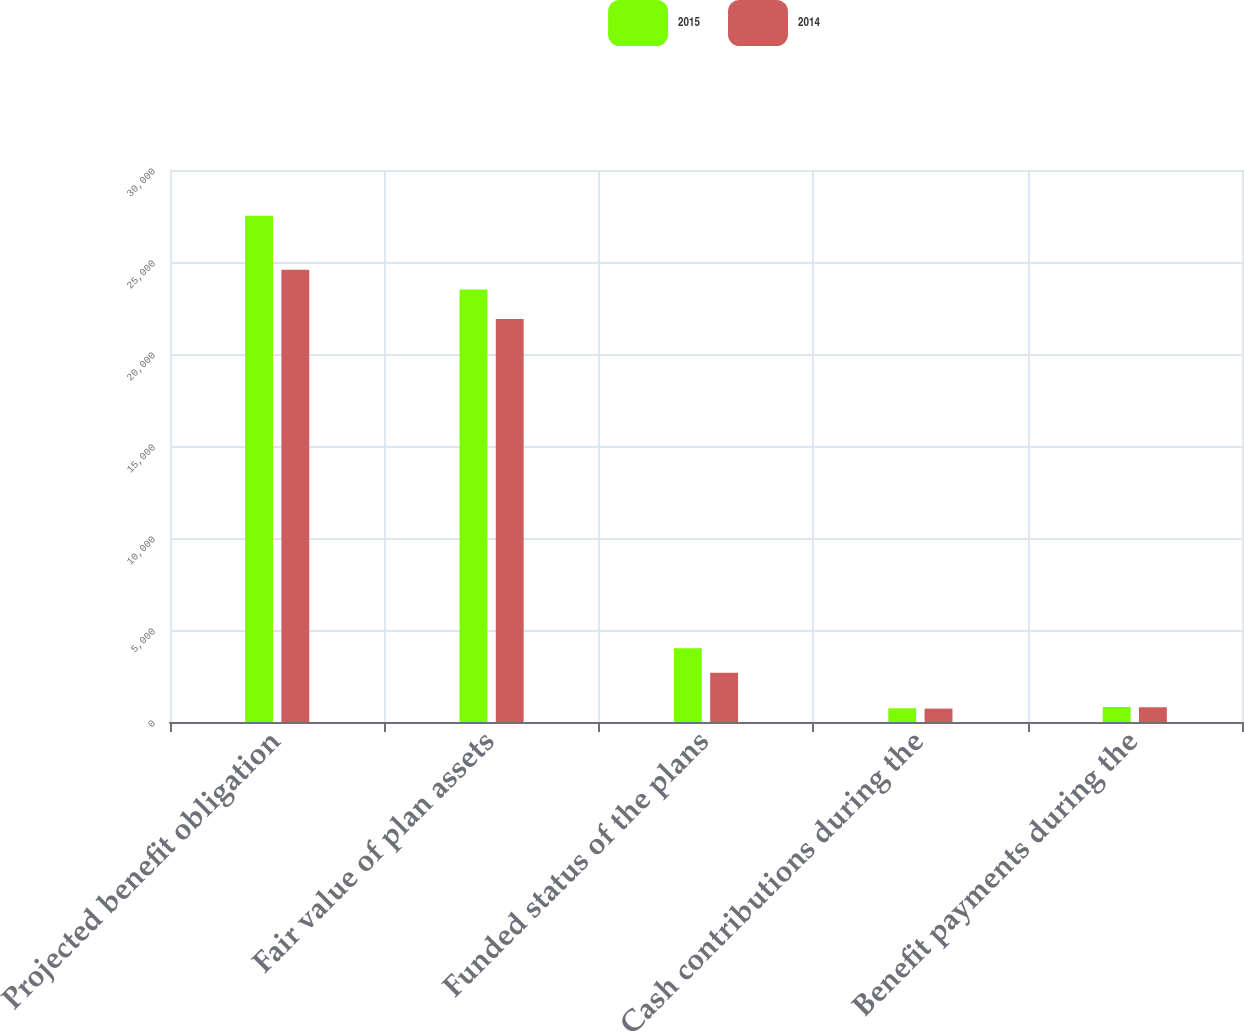Convert chart. <chart><loc_0><loc_0><loc_500><loc_500><stacked_bar_chart><ecel><fcel>Projected benefit obligation<fcel>Fair value of plan assets<fcel>Funded status of the plans<fcel>Cash contributions during the<fcel>Benefit payments during the<nl><fcel>2015<fcel>27512<fcel>23505<fcel>4007<fcel>746<fcel>815<nl><fcel>2014<fcel>24578<fcel>21907<fcel>2671<fcel>727<fcel>801<nl></chart> 